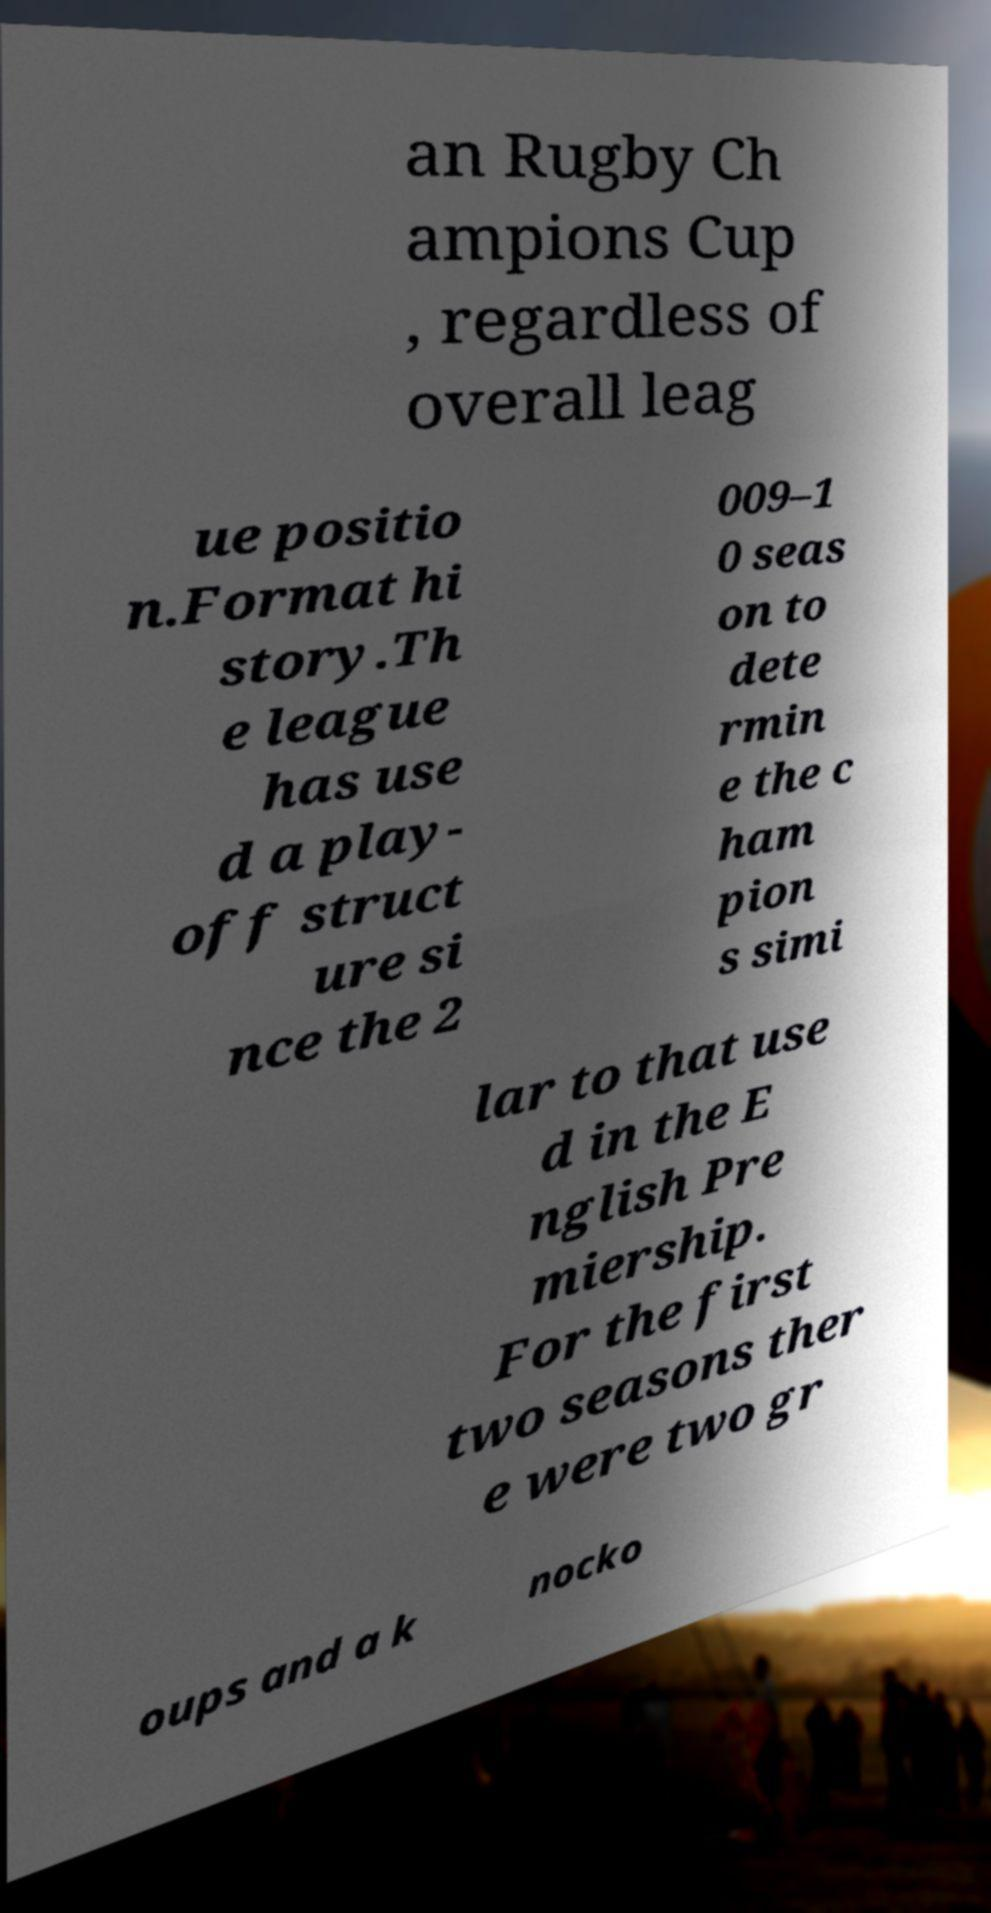What messages or text are displayed in this image? I need them in a readable, typed format. an Rugby Ch ampions Cup , regardless of overall leag ue positio n.Format hi story.Th e league has use d a play- off struct ure si nce the 2 009–1 0 seas on to dete rmin e the c ham pion s simi lar to that use d in the E nglish Pre miership. For the first two seasons ther e were two gr oups and a k nocko 